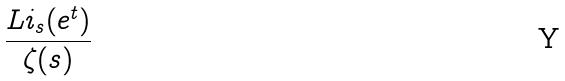Convert formula to latex. <formula><loc_0><loc_0><loc_500><loc_500>\frac { L i _ { s } ( e ^ { t } ) } { \zeta ( s ) }</formula> 